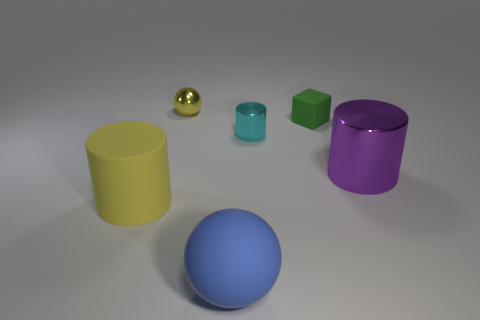Is the tiny metallic ball the same color as the rubber cylinder?
Offer a terse response. Yes. There is a rubber thing left of the ball that is behind the purple shiny cylinder; what shape is it?
Your answer should be very brief. Cylinder. What is the shape of the big yellow object that is the same material as the small green thing?
Your answer should be very brief. Cylinder. What number of other objects are the same shape as the cyan metallic thing?
Your response must be concise. 2. Does the yellow object in front of the cyan metallic cylinder have the same size as the blue sphere?
Provide a short and direct response. Yes. Are there more yellow spheres that are behind the small cylinder than large blue metal balls?
Keep it short and to the point. Yes. There is a small metallic thing on the left side of the rubber ball; what number of yellow balls are in front of it?
Provide a short and direct response. 0. Are there fewer small green objects in front of the yellow cylinder than small gray metallic blocks?
Offer a very short reply. No. Are there any big blue rubber spheres to the left of the yellow object that is in front of the tiny yellow sphere that is behind the big yellow thing?
Offer a terse response. No. Is the material of the cyan cylinder the same as the thing behind the matte cube?
Your response must be concise. Yes. 